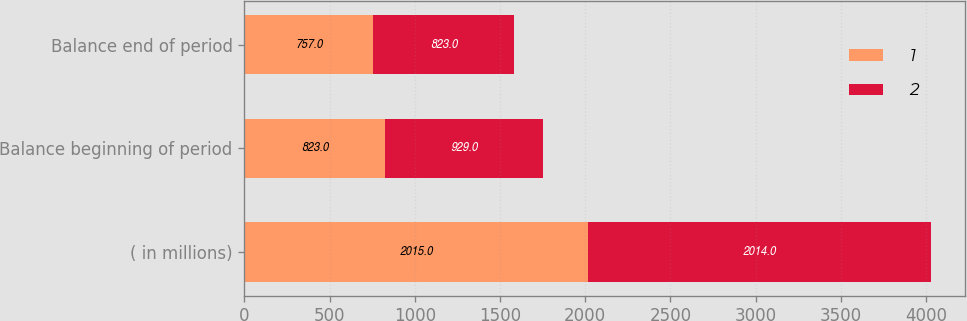Convert chart to OTSL. <chart><loc_0><loc_0><loc_500><loc_500><stacked_bar_chart><ecel><fcel>( in millions)<fcel>Balance beginning of period<fcel>Balance end of period<nl><fcel>1<fcel>2015<fcel>823<fcel>757<nl><fcel>2<fcel>2014<fcel>929<fcel>823<nl></chart> 